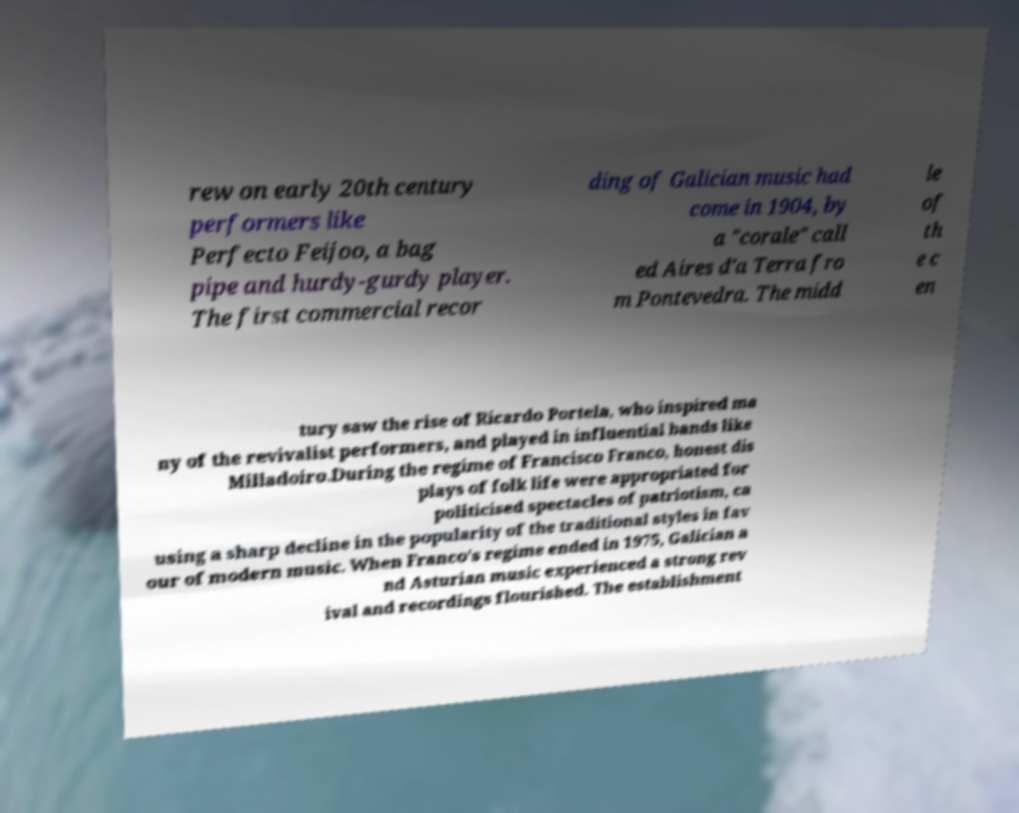Can you read and provide the text displayed in the image?This photo seems to have some interesting text. Can you extract and type it out for me? rew on early 20th century performers like Perfecto Feijoo, a bag pipe and hurdy-gurdy player. The first commercial recor ding of Galician music had come in 1904, by a "corale" call ed Aires d'a Terra fro m Pontevedra. The midd le of th e c en tury saw the rise of Ricardo Portela, who inspired ma ny of the revivalist performers, and played in influential bands like Milladoiro.During the regime of Francisco Franco, honest dis plays of folk life were appropriated for politicised spectacles of patriotism, ca using a sharp decline in the popularity of the traditional styles in fav our of modern music. When Franco's regime ended in 1975, Galician a nd Asturian music experienced a strong rev ival and recordings flourished. The establishment 